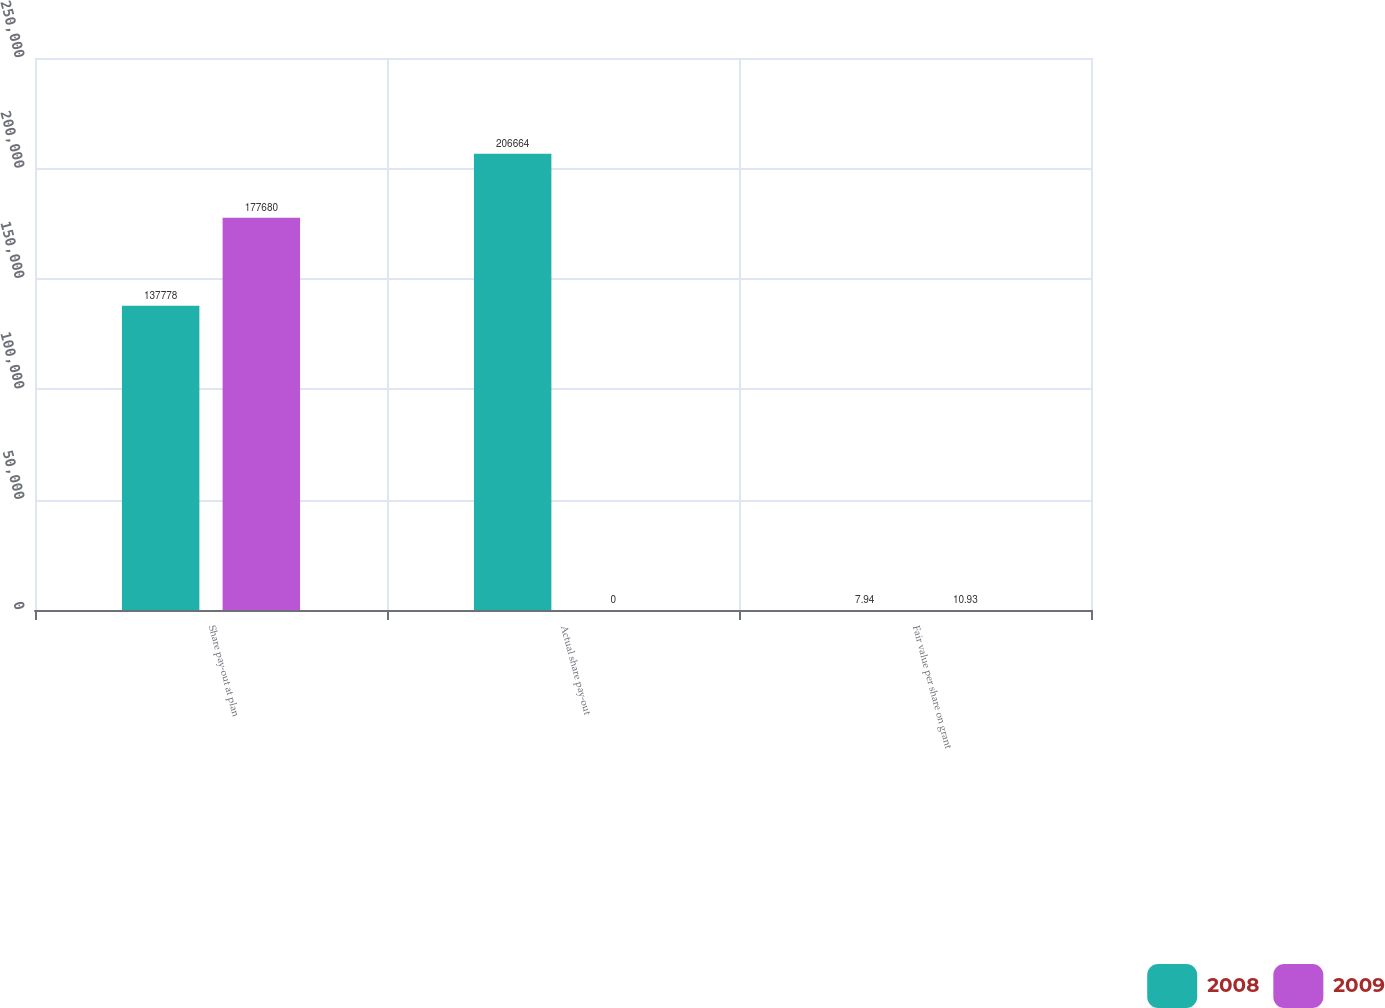Convert chart. <chart><loc_0><loc_0><loc_500><loc_500><stacked_bar_chart><ecel><fcel>Share pay-out at plan<fcel>Actual share pay-out<fcel>Fair value per share on grant<nl><fcel>2008<fcel>137778<fcel>206664<fcel>7.94<nl><fcel>2009<fcel>177680<fcel>0<fcel>10.93<nl></chart> 